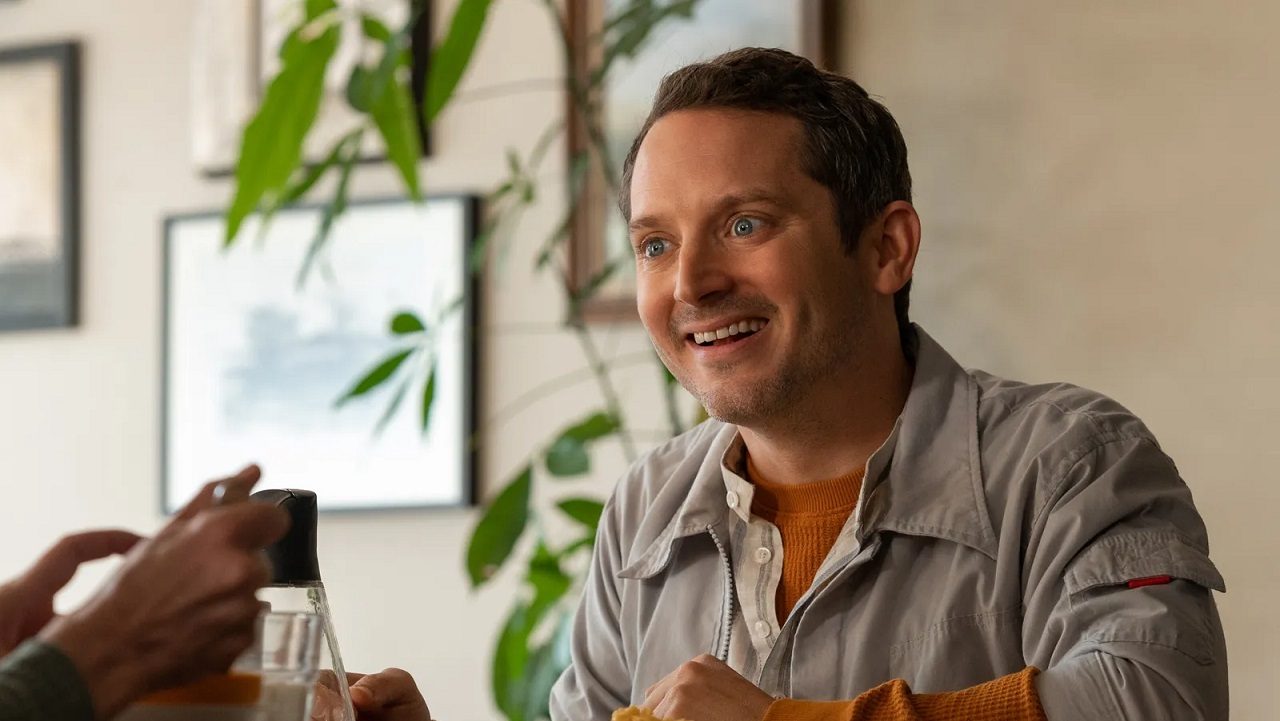Imagine a story where this scene is part of a larger narrative. In the bustling city of Melodyville, Ethan, the man in the image, had just secured a monumental contract for his budding tech start-up. To celebrate, he headed to his favorite café, an urban oasis filled with plush greenery and artful decor. Sitting across from him was Lucas, his best friend and business partner, who was equally thrilled with their success. As they enjoyed their drinks and shared stories of their journey, Ethan couldn’t help but marvel at how far they had come, from late-night brainstorming sessions to this moment of triumphant relaxation. Little did they know, this celebration would mark the beginning of a new chapter filled with unforeseen challenges and incredible opportunities. 